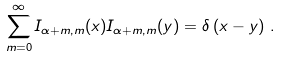<formula> <loc_0><loc_0><loc_500><loc_500>\sum _ { m = 0 } ^ { \infty } I _ { \alpha + m , m } ( x ) I _ { \alpha + m , m } ( y ) = \delta \left ( x - y \right ) \, .</formula> 